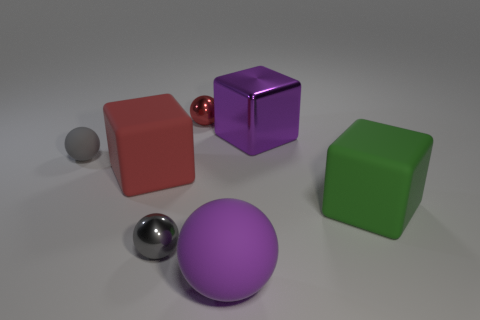How many red rubber blocks are behind the tiny shiny thing that is behind the cube left of the gray metallic sphere?
Your answer should be compact. 0. There is another matte object that is the same shape as the red rubber object; what is its size?
Offer a very short reply. Large. Is there anything else that is the same size as the purple rubber ball?
Make the answer very short. Yes. Is the number of large green blocks to the right of the green object less than the number of large shiny cubes?
Your answer should be compact. Yes. Is the shape of the big red rubber object the same as the gray matte object?
Give a very brief answer. No. There is another tiny matte object that is the same shape as the purple matte thing; what color is it?
Offer a terse response. Gray. How many other balls have the same color as the large rubber ball?
Offer a very short reply. 0. How many objects are either matte balls behind the large purple rubber object or gray rubber objects?
Make the answer very short. 1. There is a red object that is to the left of the tiny red shiny sphere; what is its size?
Keep it short and to the point. Large. Is the number of big purple cubes less than the number of gray things?
Your response must be concise. Yes. 